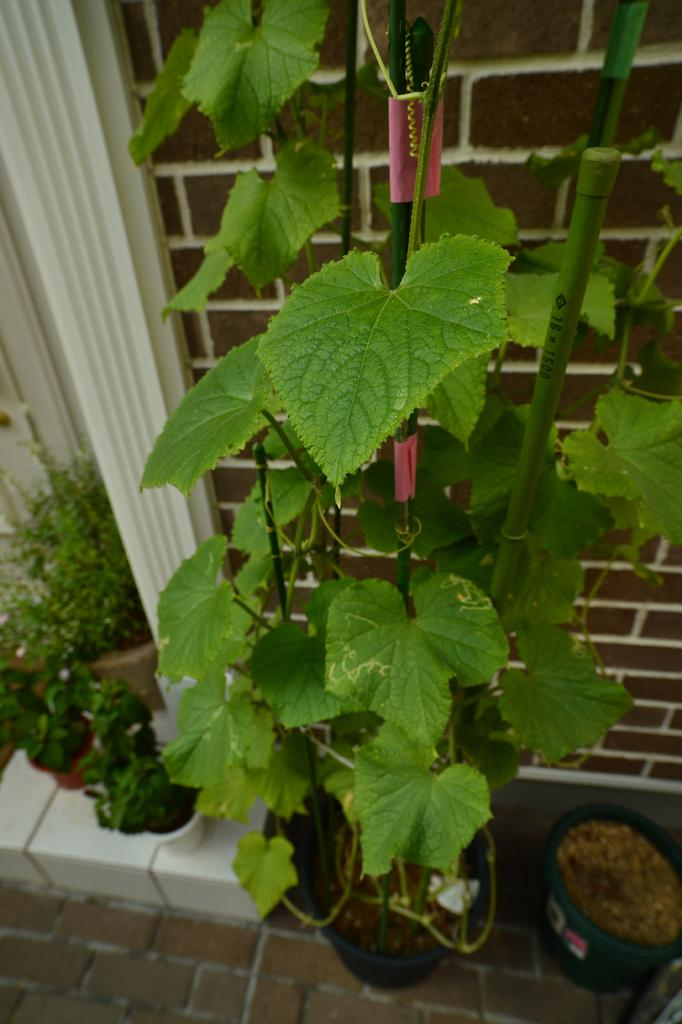What is located in the foreground of the image? There is a plant in the foreground of the image. What type of containers are present in the image? There are flower pots in the image. What else can be seen in the image besides the plant and flower pots? There are plants and sand visible in the image. What type of pathway is present in the image? There is a walkway in the image. What can be seen in the background of the image? There is a wall in the background of the image. What type of bait is being used to catch fish in the image? There is no mention of fish or bait in the image; it features a plant, flower pots, plants, sand, a walkway, and a wall in the background. What type of cemetery can be seen in the image? There is no cemetery present in the image; it features a plant, flower pots, plants, sand, a walkway, and a wall in the background. 